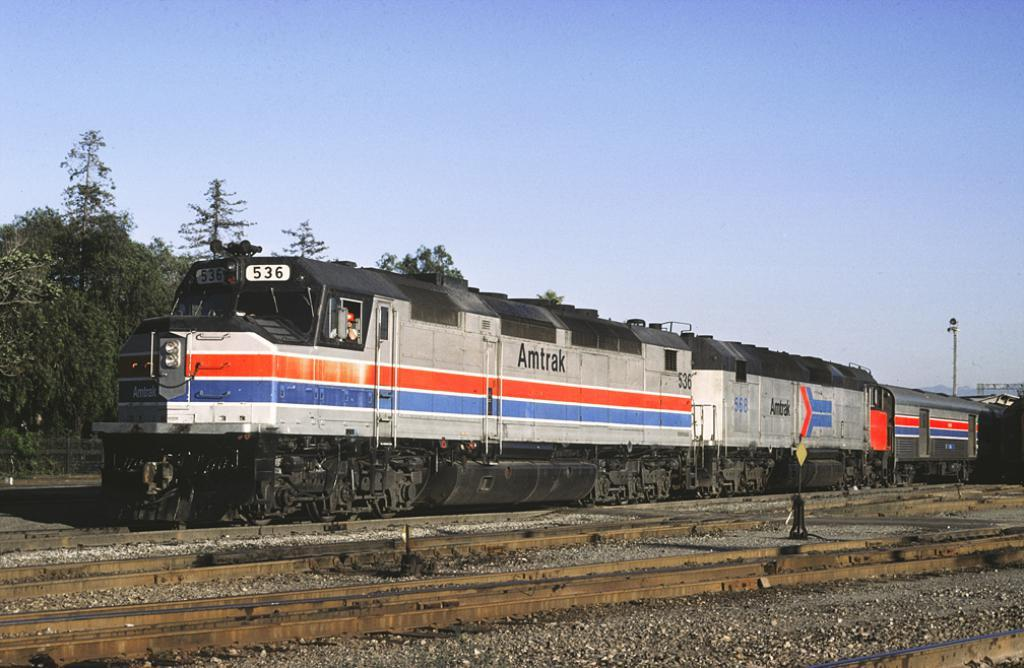What is the main subject of the image? The main subject of the image is a train. Where is the train located in the image? The train is on a railway track. What can be seen in the background of the image? There are trees and the sky visible in the background of the image. How many clovers are growing on the railway track in the image? There is no mention of clovers in the image, and they are not visible in the provided facts. 